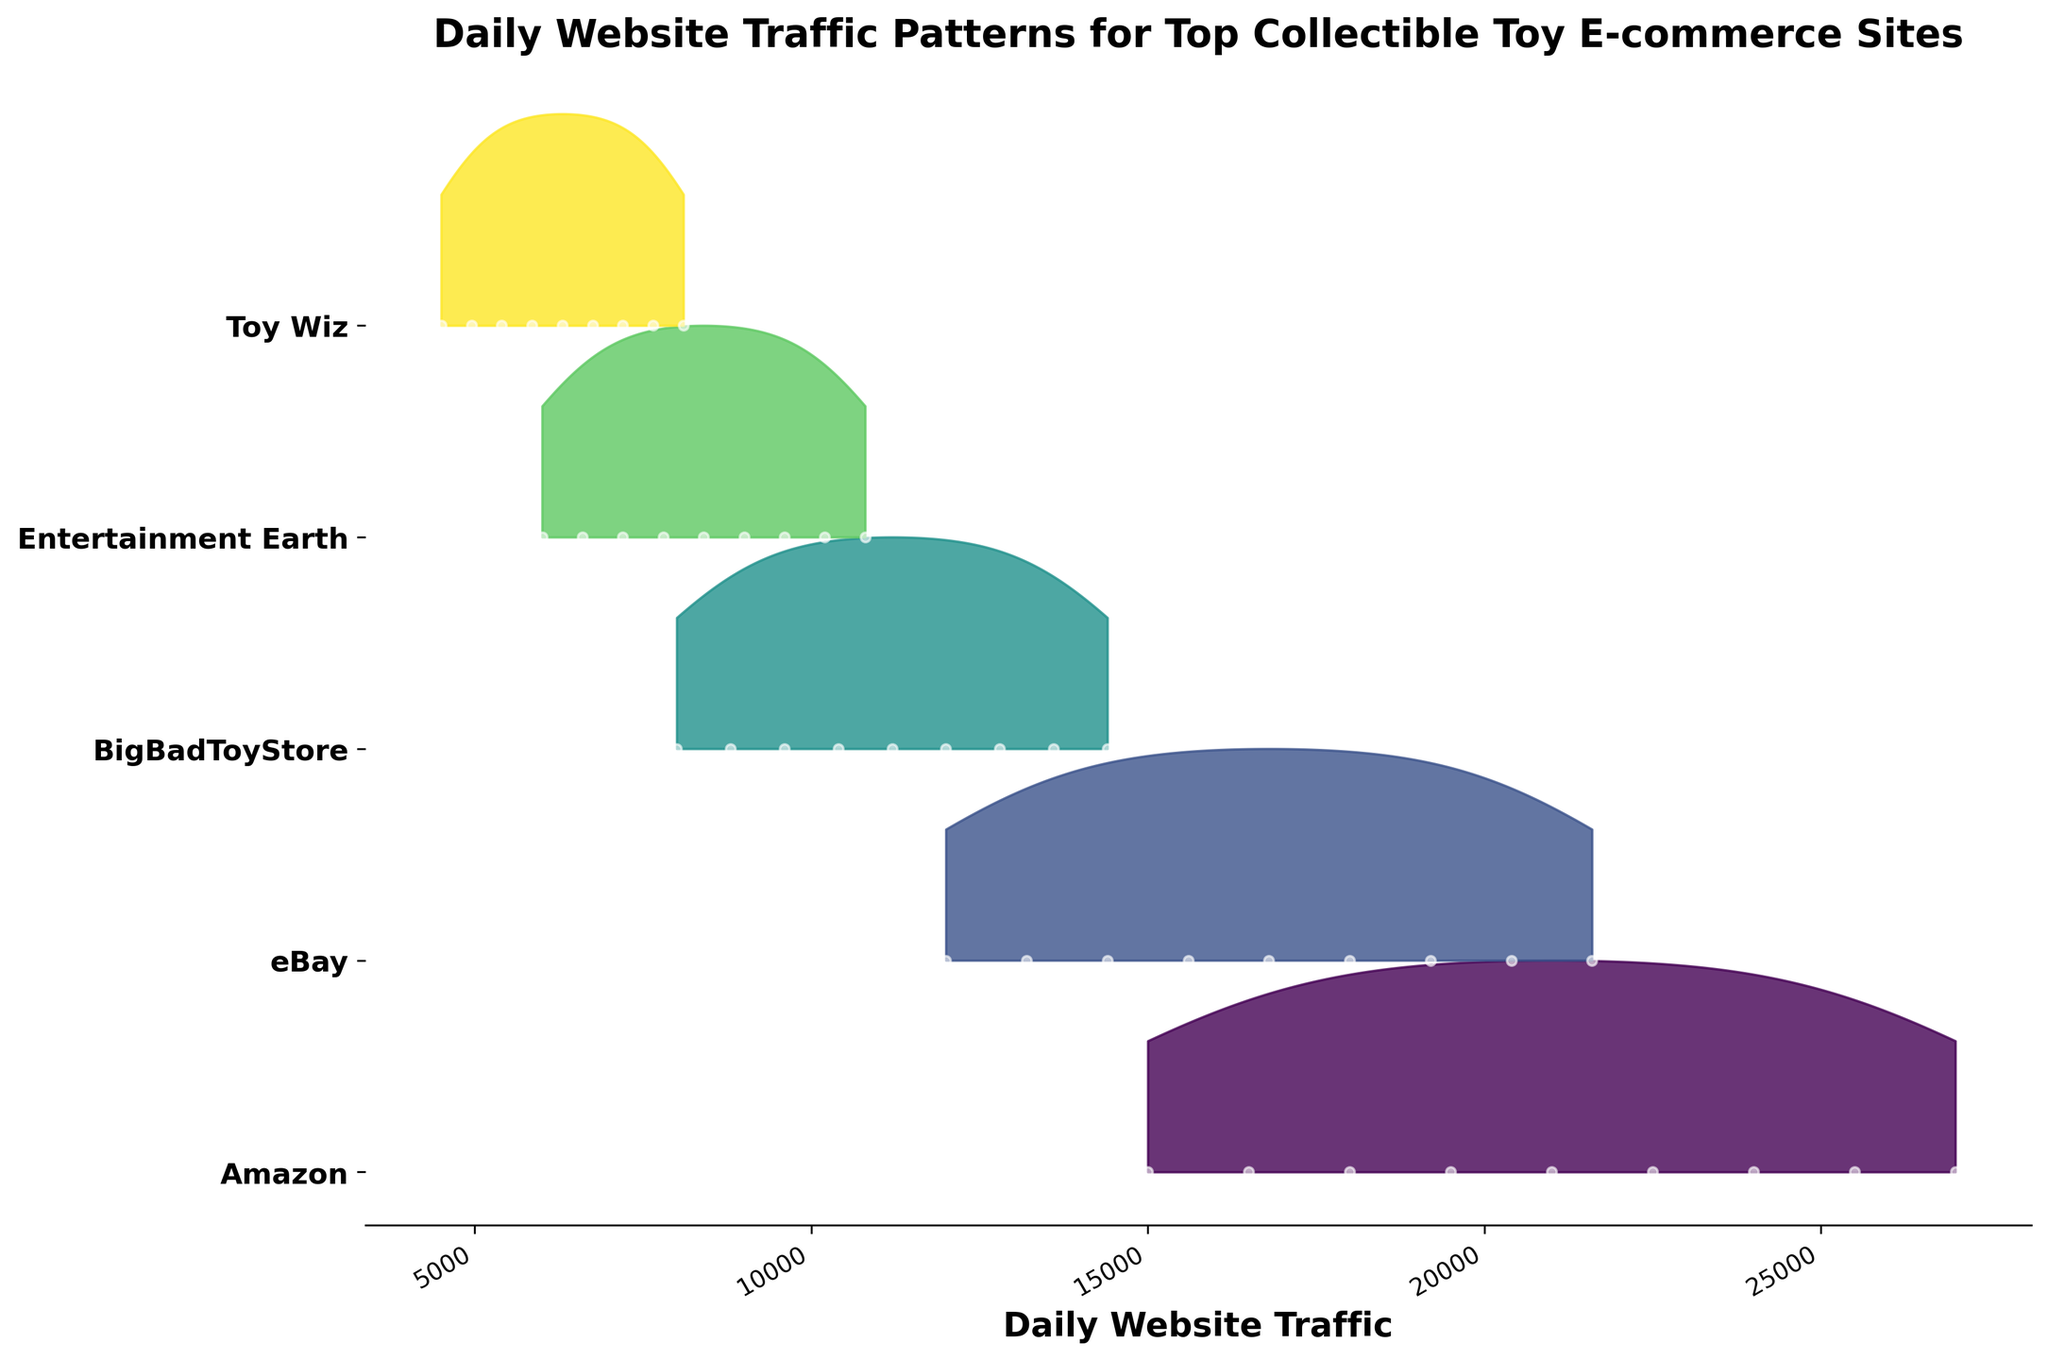What's the title of the plot? To identify the title, look at the top of the plot where the title text is usually located.
Answer: Daily Website Traffic Patterns for Top Collectible Toy E-commerce Sites Which company shows the highest peak in website traffic? To determine which company has the highest peak, compare the maximum heights of the ridgelines for each company. The company with the highest position represents the highest peak.
Answer: Amazon What is the approximate daily website traffic for eBay on 2023-12-31? Locate the data point for eBay corresponding to the date 2023-12-31. Examine where this data point is on the y-axis.
Answer: 21600 How does the website traffic pattern for BigBadToyStore compare to Entertainment Earth throughout the year? Look at the ridgelines corresponding to BigBadToyStore and Entertainment Earth, and compare the shapes and peaks. Summarize if they have similar or different trends.
Answer: Similar trend but BigBadToyStore has slightly higher peaks On which date does Toy Wiz have the lowest website traffic? Observe the points on the ridgeline corresponding to Toy Wiz and identify the date where the value is the least.
Answer: 2023-01-01 Which company shows continuous growth in daily website traffic over the year? Look for the ridgeline that consistently increases as you move from January to December. This indicates continuous growth.
Answer: Amazon What can you infer about the density spread of Entertainment Earth's daily website traffic? Examine the spread and shape of Entertainment Earth's ridgeline. Note how concentrated or spread out the density is.
Answer: Fairly consistent with mild seasonal peaks How does the website traffic of Toy Wiz compare to Amazon on 2023-09-30? Locate the data points for both Toy Wiz and Amazon on 2023-09-30 and compare their traffic numbers.
Answer: Amazon is significantly higher Which months show a noticeable increase in website traffic for all companies? Identify the dates where there is a visible upward shift in the ridgelines for all companies.
Answer: February, March, and December What is the range of website traffic values for eBay throughout the year? Find the minimum and maximum website traffic values on eBay's ridgeline to determine the range.
Answer: 12000 to 21600 